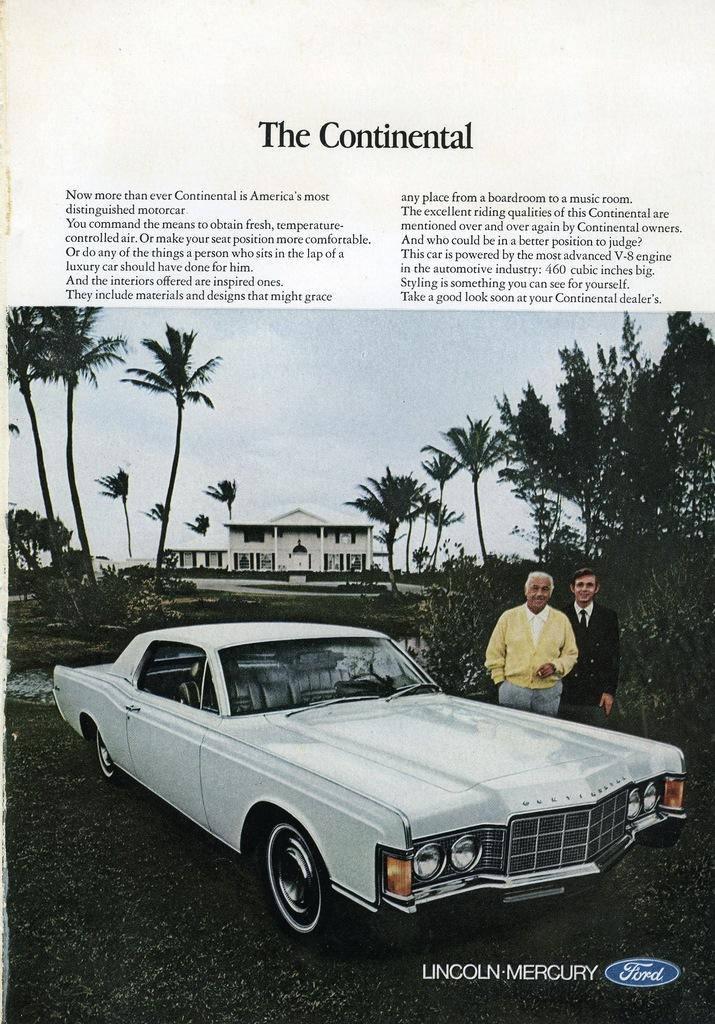What is depicted on the poster in the image? The poster features a car. Who is present in the image besides the car? There are two men standing beside the car. What can be seen in the background of the image? There are trees, a building, and the sky visible in the background of the image. Is there any text on the poster? Yes, there is text on the top of the poster. What type of egg is being cooked by the grandmother in the image? There is no egg or grandmother present in the image. What experience can be gained by looking at the poster in the image? The image does not convey any specific experience; it simply shows a poster with a car and two men standing beside it. 